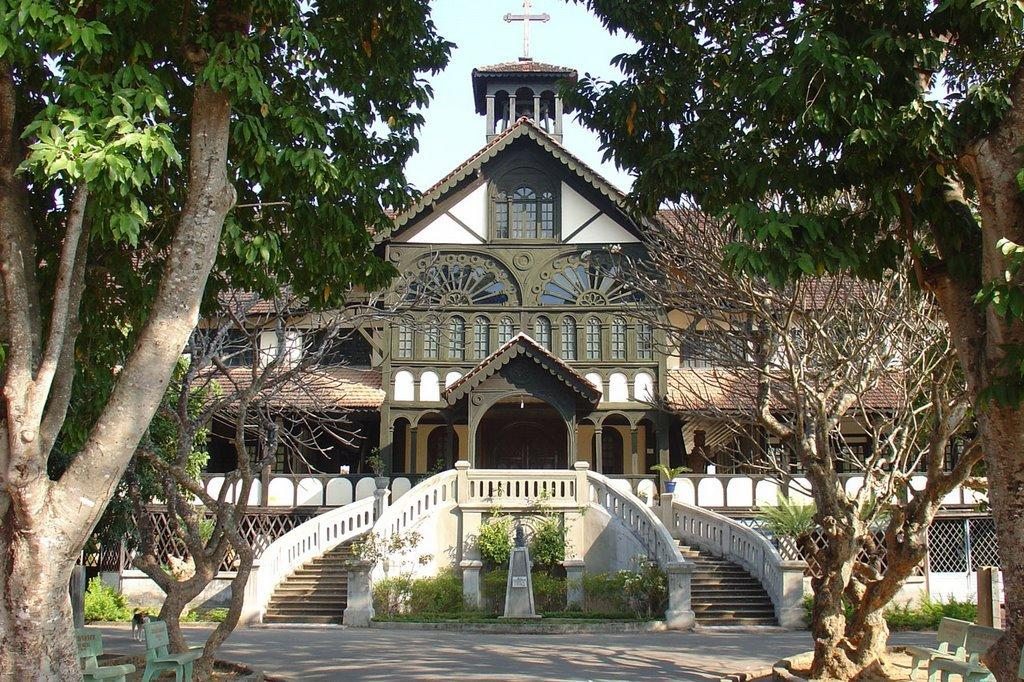What type of seating is present in the image? There are benches in the image. What type of vegetation can be seen in the image? There are plants and trees in the image. What type of animal is present in the image? There is a dog in the image. What type of man-made structure is present in the image? There is a building in the image. What type of pathway is present in the image? There is a road in the image. What can be seen in the background of the image? The sky is visible in the background of the image. What type of veil is the daughter wearing in the image? There is no daughter or veil present in the image. What type of role is the actor playing in the image? There is no actor or role present in the image. 